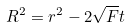<formula> <loc_0><loc_0><loc_500><loc_500>R ^ { 2 } = r ^ { 2 } - 2 \sqrt { F } t</formula> 